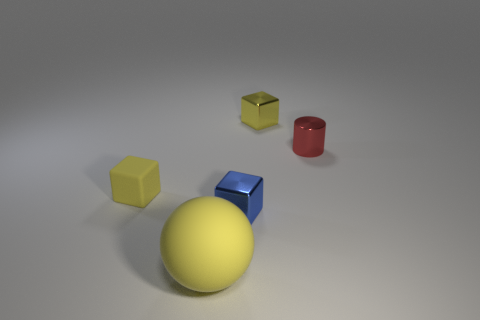Can you speculate on the material of the objects? The objects seem to be made of different materials. The large yellow ball and the small yellow cubes have a matte finish, suggesting a material like plastic or painted wood. The blue cube has a reflective surface hinting at a metallic nature. The red cylinder, with its high shine, could be ceramic or polished metal. 